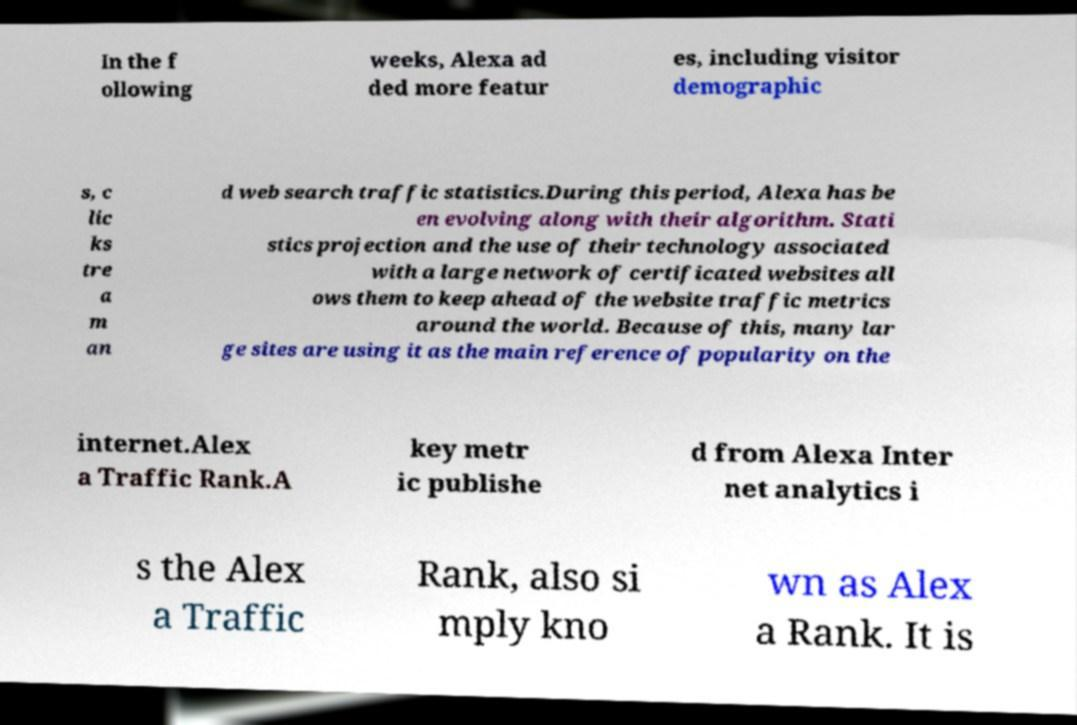There's text embedded in this image that I need extracted. Can you transcribe it verbatim? In the f ollowing weeks, Alexa ad ded more featur es, including visitor demographic s, c lic ks tre a m an d web search traffic statistics.During this period, Alexa has be en evolving along with their algorithm. Stati stics projection and the use of their technology associated with a large network of certificated websites all ows them to keep ahead of the website traffic metrics around the world. Because of this, many lar ge sites are using it as the main reference of popularity on the internet.Alex a Traffic Rank.A key metr ic publishe d from Alexa Inter net analytics i s the Alex a Traffic Rank, also si mply kno wn as Alex a Rank. It is 